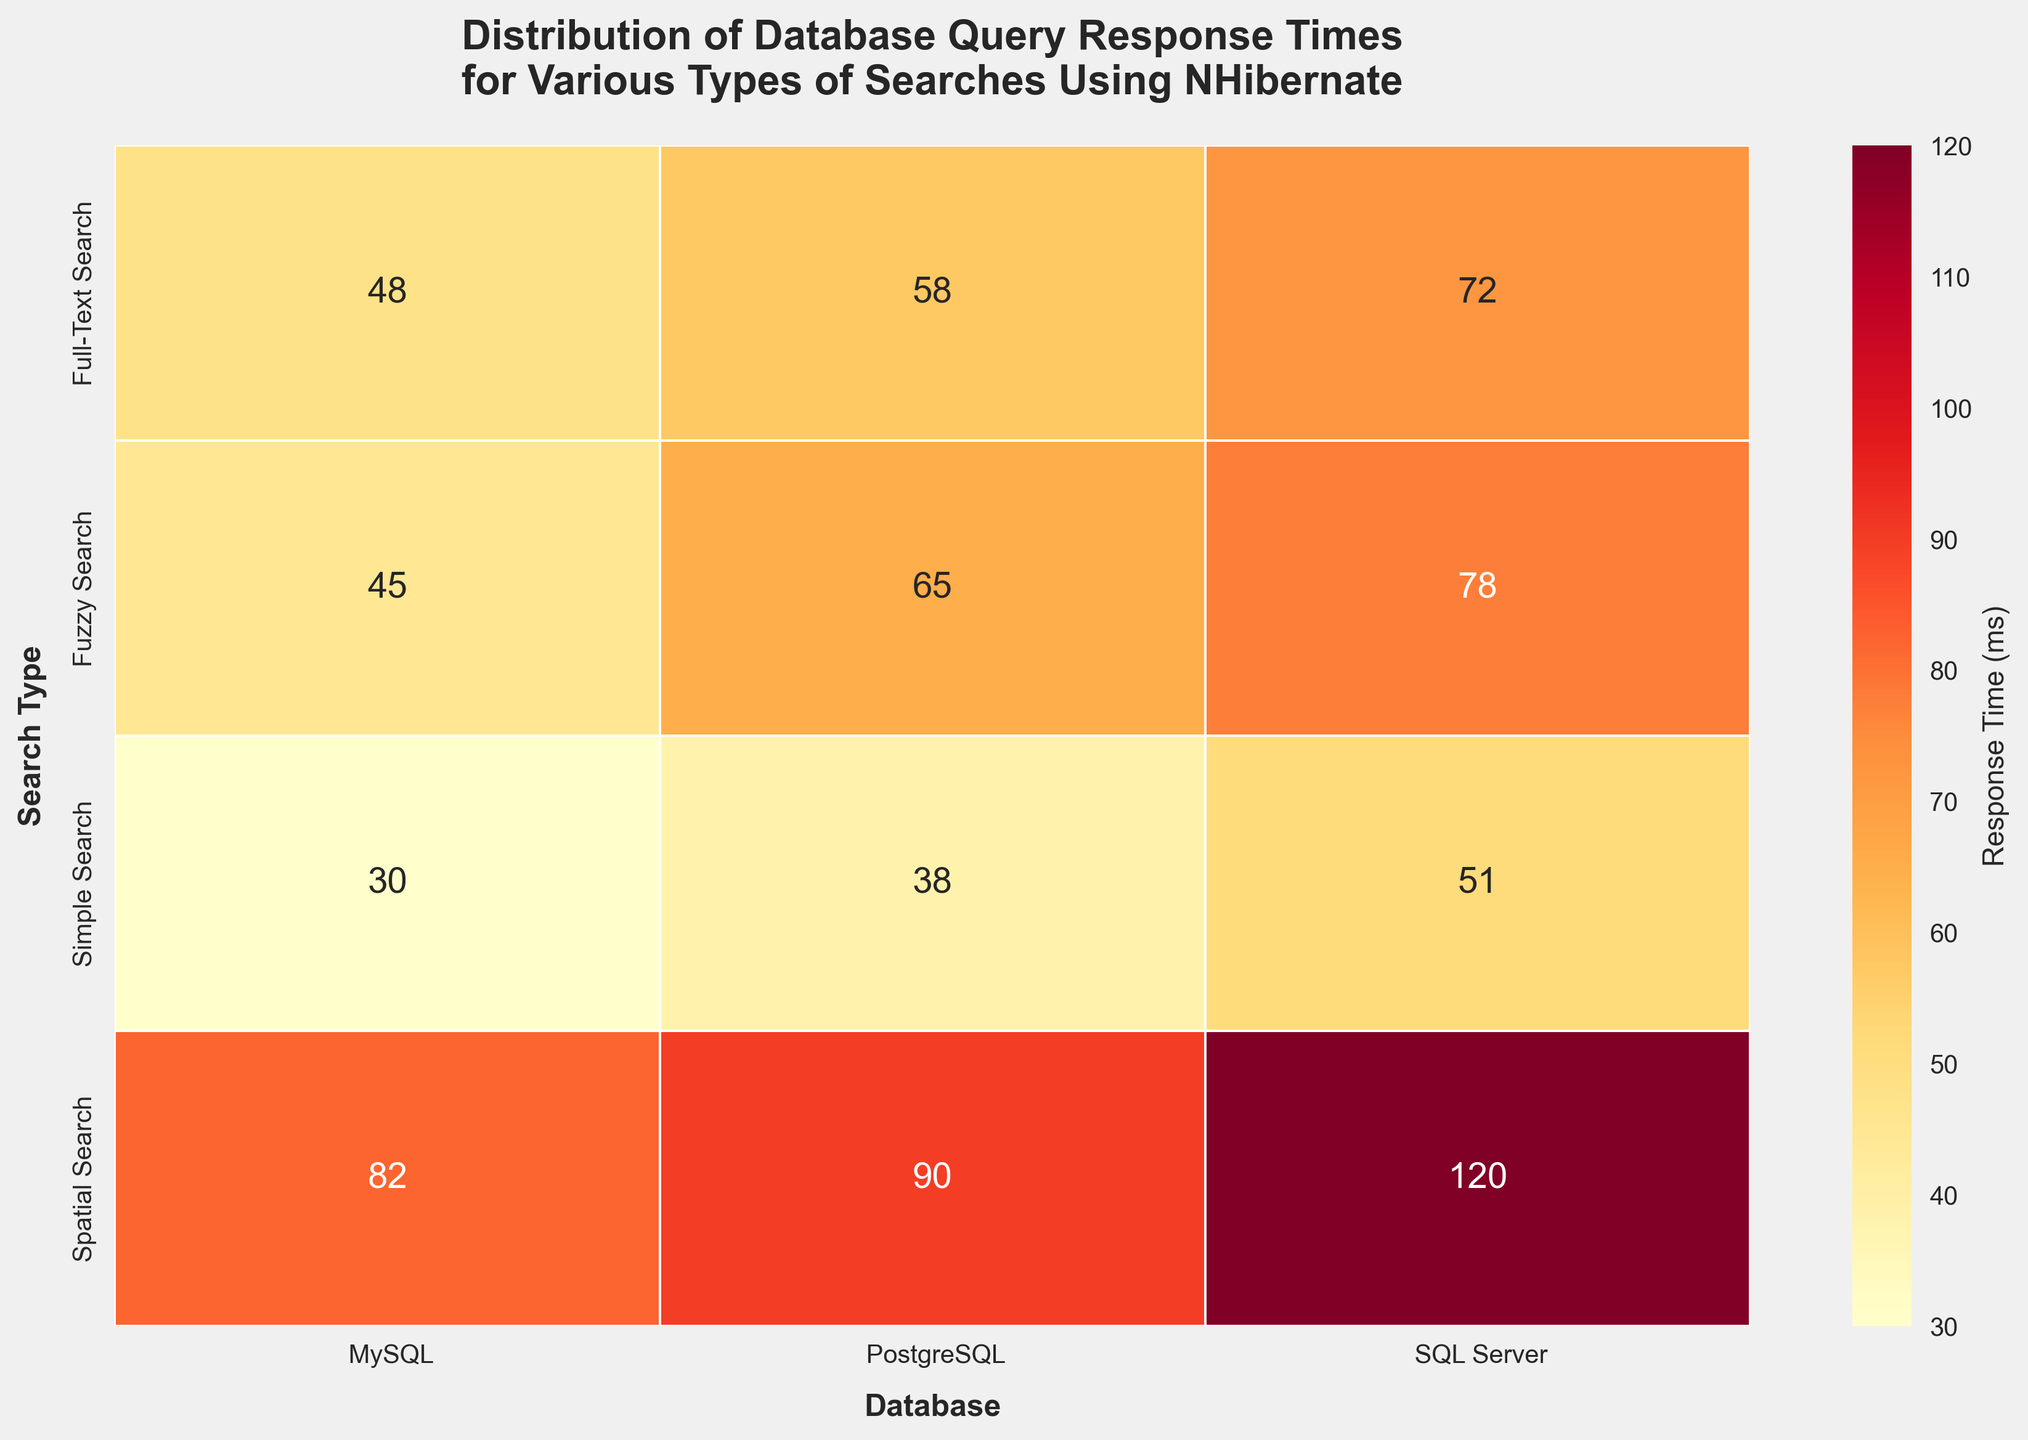What's the title of the figure? The title is displayed at the top of the figure in larger, bold font. For this specific figure, the title is designed to provide a concise summary of the data being visualized. It reads: "Distribution of Database Query Response Times for Various Types of Searches Using NHibernate".
Answer: Distribution of Database Query Response Times for Various Types of Searches Using NHibernate Which database has the highest average response time for Spatial Search? To find the highest average response time for Spatial Search, locate the row labeled “Spatial Search” and find the maximum value in that row. For Spatial Search, the average response times are 90 ms, 82 ms, and 120 ms for PostgreSQL, MySQL, and SQL Server, respectively. SQL Server has the highest value.
Answer: SQL Server Which search type generally performs fastest on MySQL? Look at the average response time values under the MySQL column for different search types (Simple, Fuzzy, Spatial, Full-Text). Compare these values to identify the smallest one. Simple Search on MySQL has average response times of 25 ms, 35 ms, and 30 ms, which are all lower than the other search types.
Answer: Simple Search How does the average response time for Full-Text Search on PostgreSQL compare to that on SQL Server? First, find the average response time for Full-Text Search on PostgreSQL and SQL Server. These are 58 ms and 72 ms, respectively. Then, compare these values. PostgreSQL has a lower response time than SQL Server for Full-Text Search.
Answer: PostgreSQL has a lower average response time What is the difference in average response time between the fastest and slowest search types on SQL Server? Identify the smallest and largest average response times on SQL Server across all search types. The smallest is for Simple Search (51 ms) and the largest is for Spatial Search (120 ms). Calculate the difference: 120 ms - 51 ms = 69 ms.
Answer: 69 ms Which search type shows the least variation in response times across all databases? Check the row-wise data across all databases for each search type and calculate the variation, such as standard deviation, if needed. In this case, visually assessing the closeness of values works: Simple Search has consistent response times around 30-55 ms across databases, indicating least variation.
Answer: Simple Search How does the average response time for Spatial Search on PostgreSQL compare to the same search type on MySQL? Locate the values for Spatial Search under PostgreSQL (90 ms) and MySQL (82 ms). Compare these values. PostgreSQL's 90 ms is higher than MySQL's 82 ms.
Answer: PostgreSQL has a higher average response time Which database generally performs better for Fuzzy Search? Compare the average response times for Fuzzy Search across PostgreSQL, MySQL, and SQL Server. PostgreSQL has an average of 65 ms, MySQL has 45 ms, and SQL Server has 78 ms. MySQL has the lowest response time, indicating better performance.
Answer: MySQL 